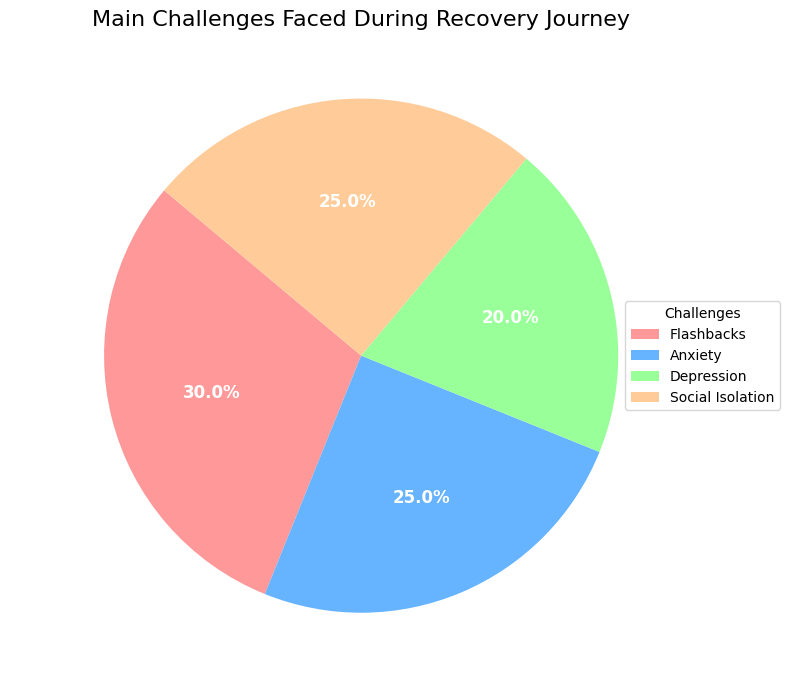What is the percentage of people who faced Flashbacks as a challenge? The pie chart shows labels with percentages for each challenge. Looking at the label for Flashbacks, it indicates 30.0%.
Answer: 30.0% Which two challenges are faced by an equal percentage of people? The pie chart indicates that Anxiety and Social Isolation both constitute 25% of the challenges faced.
Answer: Anxiety & Social Isolation What is the sum of the percentages for Depression and Social Isolation? Depression accounts for 20% and Social Isolation accounts for 25%. Summing these two percentages: 20% + 25% = 45%.
Answer: 45% Is the percentage of people who faced Flashbacks greater than those who faced Anxiety? Flashbacks constitute 30% while Anxiety constitutes 25%. Since 30% is greater than 25%, Flashbacks is greater.
Answer: Yes What is the difference in percentage between those who faced the highest and the lowest challenge? The highest challenge is Flashbacks at 30% and the lowest is Depression at 20%. Difference: 30% - 20% = 10%.
Answer: 10% What is the average percentage of people who faced Anxiety, Depression, and Social Isolation? Sum the percentages for Anxiety (25%), Depression (20%), and Social Isolation (25%), then divide by 3: (25% + 20% + 25%)/3 = 23.33%.
Answer: 23.33% Which challenge has the smallest segment in the pie chart? Visually, the segment for Depression is the smallest, constituting 20% of the total.
Answer: Depression What is the combined percentage of people who faced Anxiety and Social Isolation compared to those who faced Flashbacks? Anxiety and Social Isolation both are 25% each, combined is 50%, Flashbacks is 30%, so combined percentage of Anxiety and Social Isolation is greater than Flashbacks: 50% > 30%.
Answer: Greater than What proportion of the pie chart is accounted for by Anxiety alone? The pie chart label for Anxiety indicates 25%, so Anxiety alone accounts for 25% of the pie chart.
Answer: 25% 